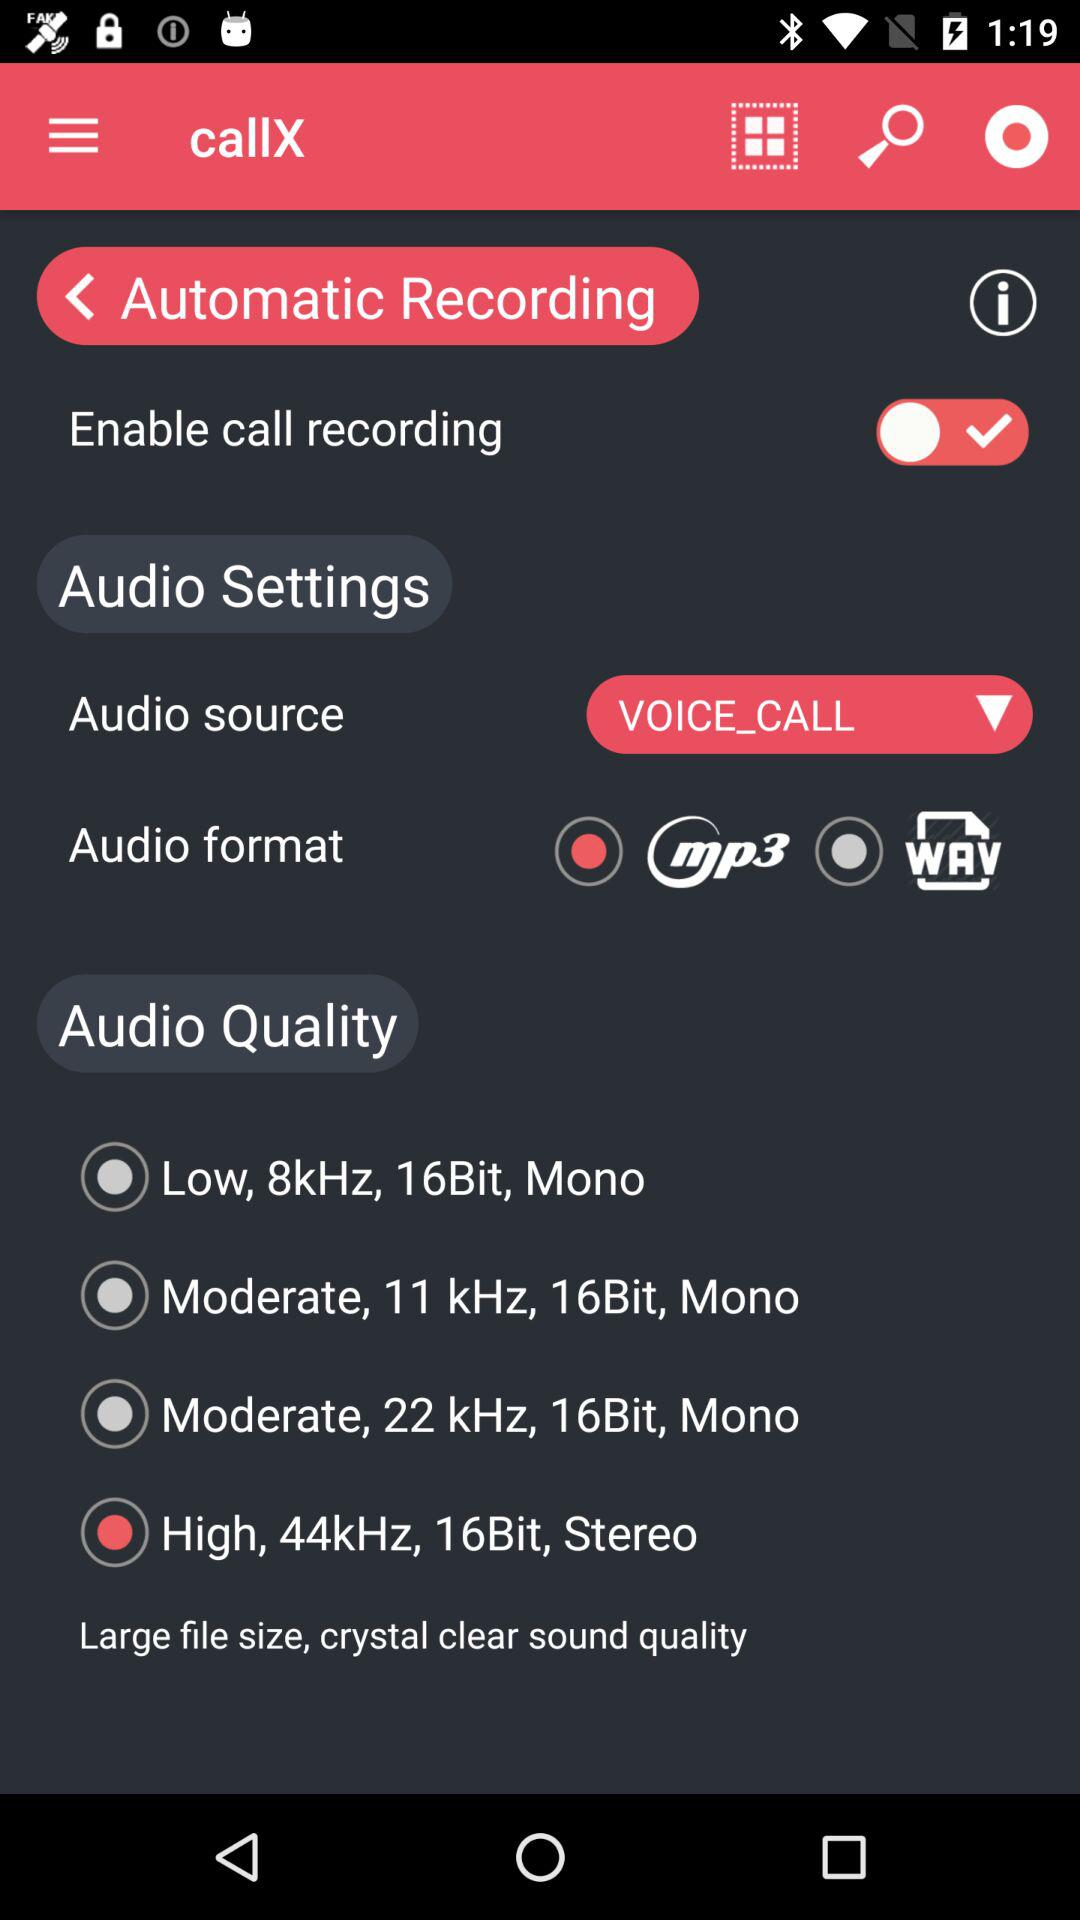Which options are available under the "Audio Quality"? The available options are "Low, 8kHz, 16Bit, Mono", "Moderate, 11 kHz, 16Bit, Mono", "Moderate, 22 kHz, 16Bit, Mono" and "High, 44kHz, 16Bit, Stereo". 